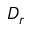<formula> <loc_0><loc_0><loc_500><loc_500>D _ { r }</formula> 